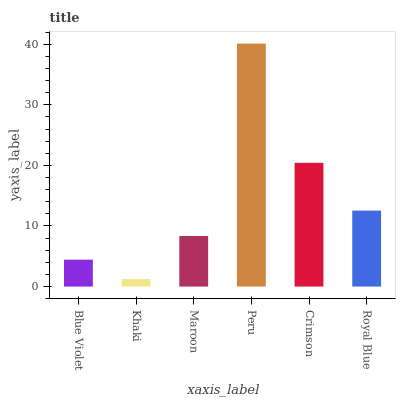Is Maroon the minimum?
Answer yes or no. No. Is Maroon the maximum?
Answer yes or no. No. Is Maroon greater than Khaki?
Answer yes or no. Yes. Is Khaki less than Maroon?
Answer yes or no. Yes. Is Khaki greater than Maroon?
Answer yes or no. No. Is Maroon less than Khaki?
Answer yes or no. No. Is Royal Blue the high median?
Answer yes or no. Yes. Is Maroon the low median?
Answer yes or no. Yes. Is Blue Violet the high median?
Answer yes or no. No. Is Royal Blue the low median?
Answer yes or no. No. 